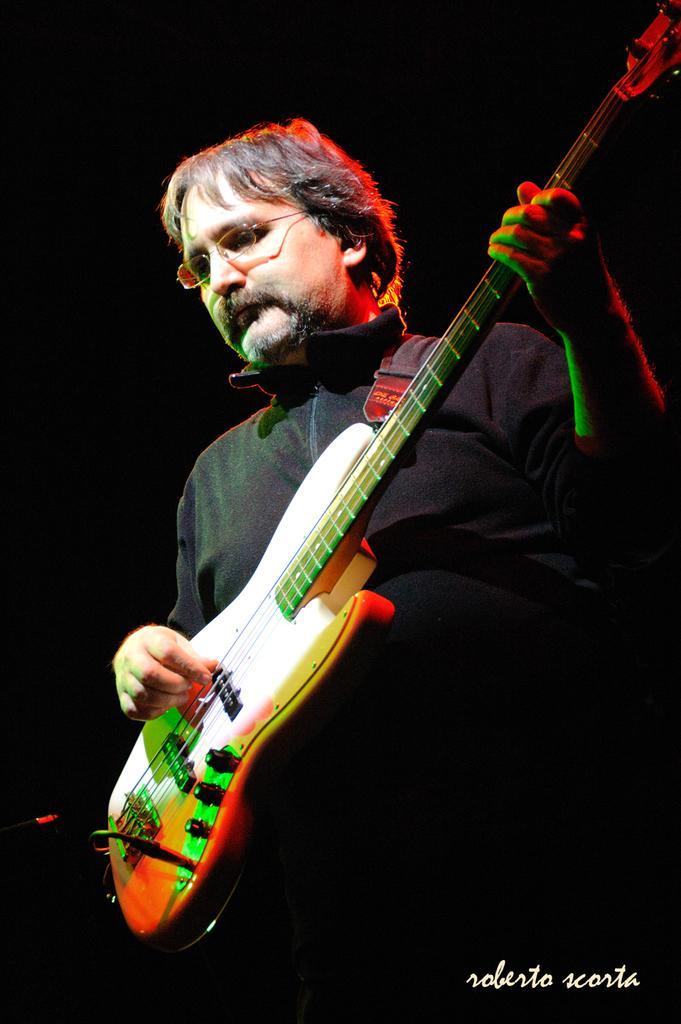Please provide a concise description of this image. This picture shows a man playing guitar. 